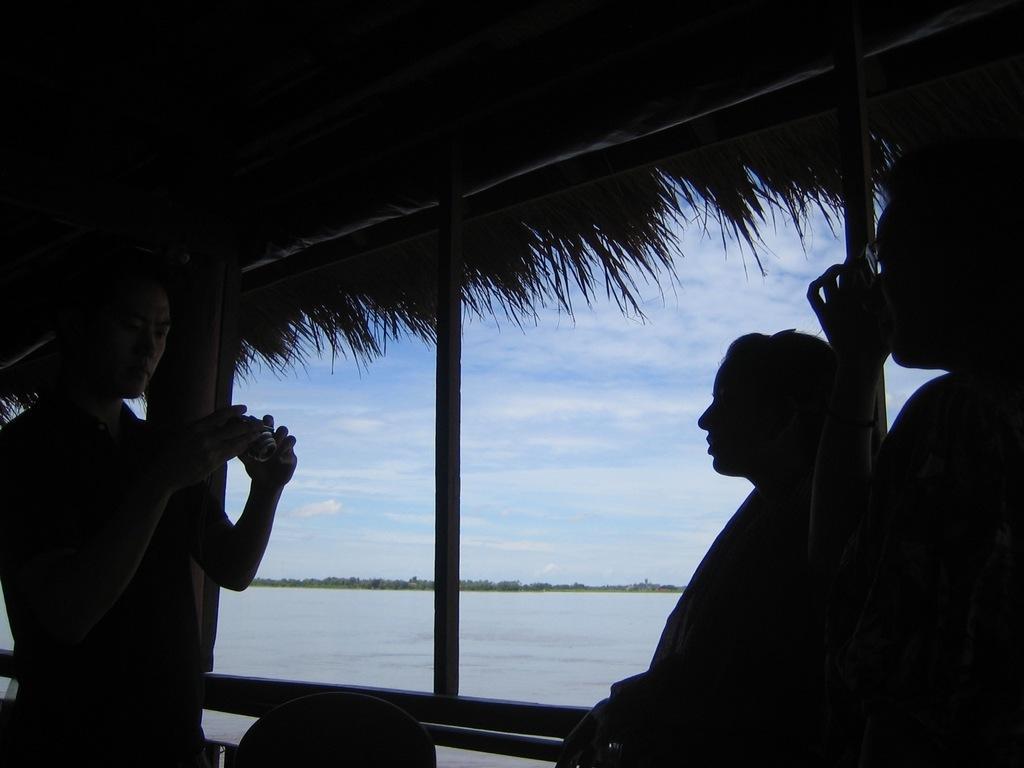Describe this image in one or two sentences. In the image we can see the person on the left side is holding a camera and standing and we can see two persons standing on the left right side of the image and they are in the dark. Here we can see the water, trees and the sky with clouds in the background. 